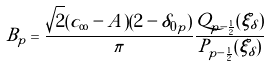Convert formula to latex. <formula><loc_0><loc_0><loc_500><loc_500>B _ { p } = \frac { \sqrt { 2 } ( c _ { \infty } - A ) ( 2 - \delta _ { 0 p } ) } { \pi } \frac { Q _ { p - \frac { 1 } { 2 } } ( \xi _ { \delta } ) } { P _ { p - \frac { 1 } { 2 } } ( \xi _ { \delta } ) }</formula> 